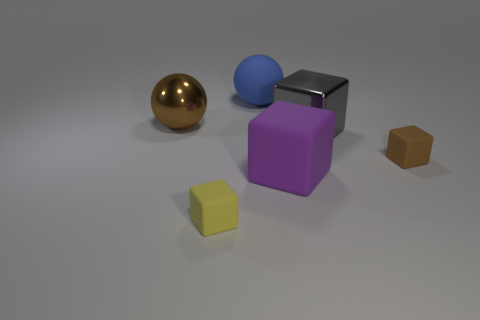Are there any objects in the shadow of the purple cube? Yes, the small brown cube is partly in the shadow cast by the purple cube. 